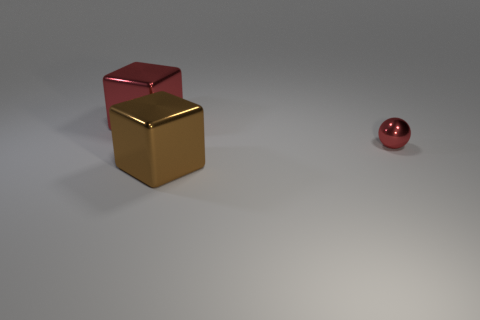Add 3 large red shiny things. How many objects exist? 6 Subtract all blocks. How many objects are left? 1 Add 2 brown metal blocks. How many brown metal blocks are left? 3 Add 1 large brown metallic spheres. How many large brown metallic spheres exist? 1 Subtract 0 green cylinders. How many objects are left? 3 Subtract all big brown metallic things. Subtract all large brown cubes. How many objects are left? 1 